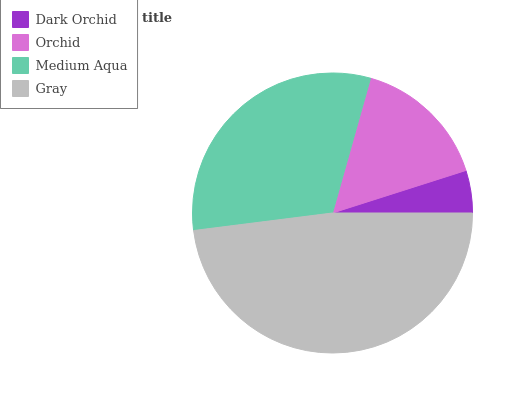Is Dark Orchid the minimum?
Answer yes or no. Yes. Is Gray the maximum?
Answer yes or no. Yes. Is Orchid the minimum?
Answer yes or no. No. Is Orchid the maximum?
Answer yes or no. No. Is Orchid greater than Dark Orchid?
Answer yes or no. Yes. Is Dark Orchid less than Orchid?
Answer yes or no. Yes. Is Dark Orchid greater than Orchid?
Answer yes or no. No. Is Orchid less than Dark Orchid?
Answer yes or no. No. Is Medium Aqua the high median?
Answer yes or no. Yes. Is Orchid the low median?
Answer yes or no. Yes. Is Gray the high median?
Answer yes or no. No. Is Gray the low median?
Answer yes or no. No. 